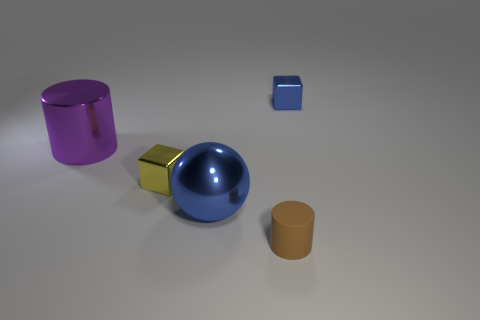What is the material of the block that is on the left side of the tiny block that is behind the small thing that is on the left side of the metal sphere?
Your response must be concise. Metal. Is there anything else that is the same material as the small blue thing?
Give a very brief answer. Yes. Is the color of the small block to the right of the tiny cylinder the same as the matte object?
Your answer should be very brief. No. What number of brown things are matte cubes or small metal cubes?
Ensure brevity in your answer.  0. How many other things are the same shape as the big purple object?
Ensure brevity in your answer.  1. Is the blue block made of the same material as the brown thing?
Offer a very short reply. No. There is a thing that is right of the large blue shiny thing and in front of the small yellow shiny object; what material is it?
Provide a short and direct response. Rubber. What color is the shiny object in front of the small yellow block?
Your answer should be compact. Blue. Is the number of blue blocks that are to the left of the purple cylinder greater than the number of metal spheres?
Provide a short and direct response. No. How many other objects are the same size as the sphere?
Ensure brevity in your answer.  1. 